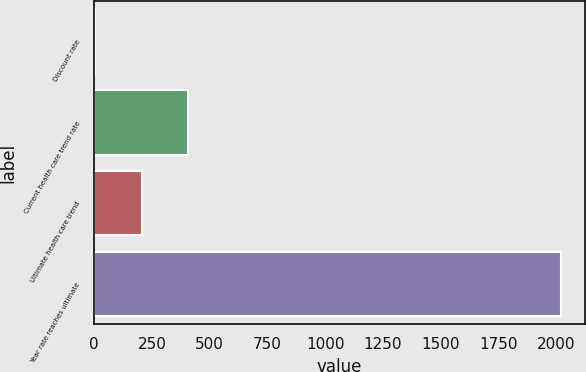Convert chart to OTSL. <chart><loc_0><loc_0><loc_500><loc_500><bar_chart><fcel>Discount rate<fcel>Current health care trend rate<fcel>Ultimate health care trend<fcel>Year rate reaches ultimate<nl><fcel>3.45<fcel>407.37<fcel>205.41<fcel>2023<nl></chart> 